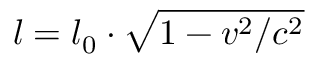<formula> <loc_0><loc_0><loc_500><loc_500>l = l _ { 0 } \cdot { \sqrt { 1 - v ^ { 2 } / c ^ { 2 } } }</formula> 